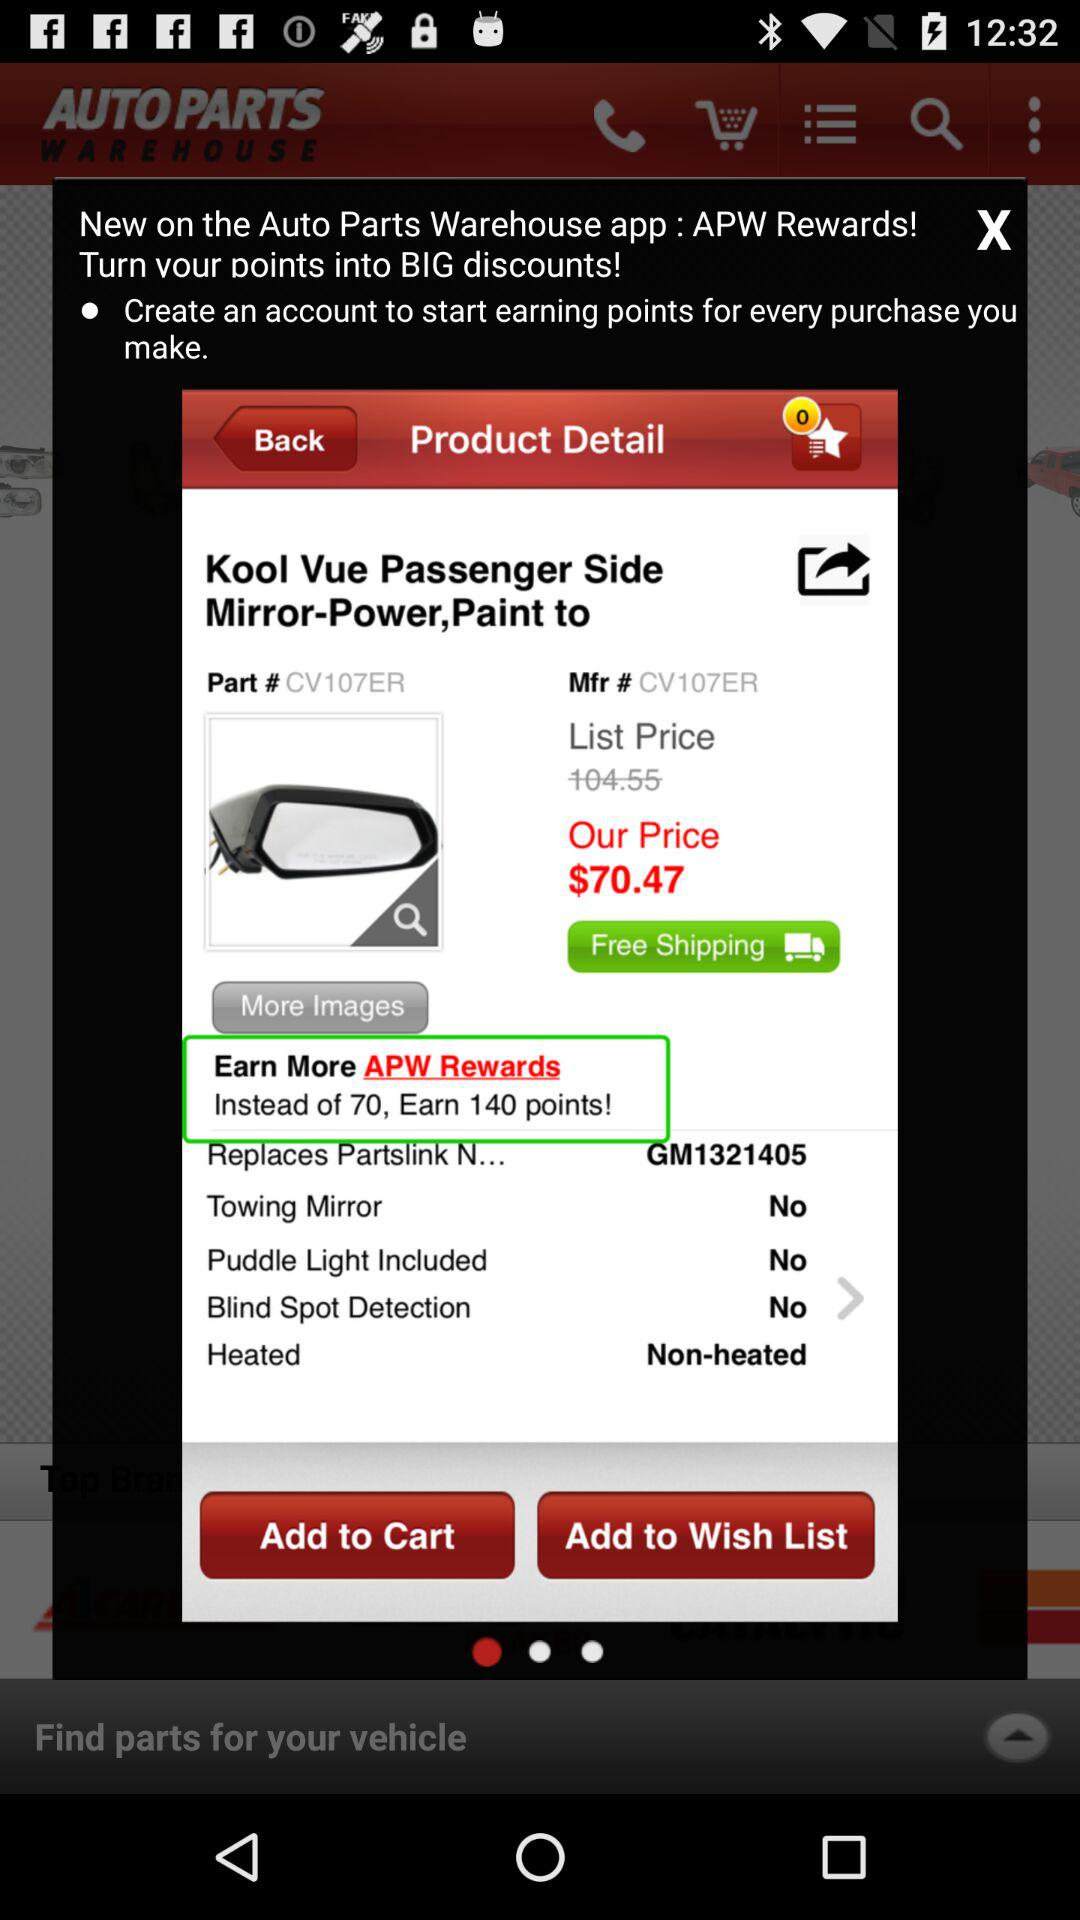Does "Kool Vue Passenger Side Mirror-Power,Paint to" have a towing mirror? There is no towing mirror on "Kool Vue Passenger Side Mirror-Power,Paint to". 